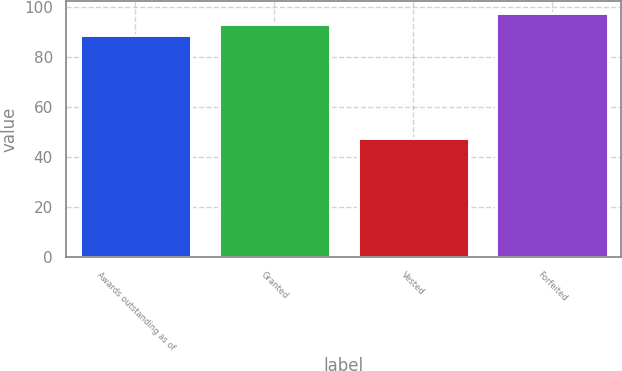Convert chart. <chart><loc_0><loc_0><loc_500><loc_500><bar_chart><fcel>Awards outstanding as of<fcel>Granted<fcel>Vested<fcel>Forfeited<nl><fcel>88.75<fcel>93.17<fcel>47.71<fcel>97.59<nl></chart> 